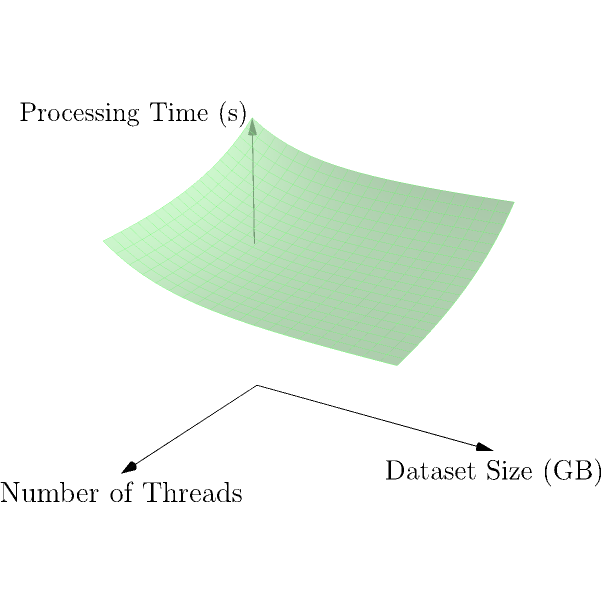The surface shown in the graph represents the relationship between processing time (z-axis), number of threads (x-axis), and dataset size (y-axis) for a multi-threading algorithm. The surface is defined by the function:

$$ f(x,y) = 100 + 50e^{-x/10} + 30e^{-y/5} $$

where $x$ represents the number of threads, $y$ represents the dataset size in GB, and $f(x,y)$ represents the processing time in seconds.

Calculate the volume enclosed between this surface and the xy-plane for $x \in [0,20]$ and $y \in [0,20]$. To find the volume enclosed between the surface and the xy-plane, we need to calculate a double integral over the given domain. The steps are as follows:

1) The volume is given by the double integral:

   $$ V = \int_{0}^{20} \int_{0}^{20} f(x,y) \, dx \, dy $$

2) Substituting the function:

   $$ V = \int_{0}^{20} \int_{0}^{20} (100 + 50e^{-x/10} + 30e^{-y/5}) \, dx \, dy $$

3) We can split this into three integrals:

   $$ V = \int_{0}^{20} \int_{0}^{20} 100 \, dx \, dy + \int_{0}^{20} \int_{0}^{20} 50e^{-x/10} \, dx \, dy + \int_{0}^{20} \int_{0}^{20} 30e^{-y/5} \, dx \, dy $$

4) Evaluating the first integral:

   $$ V_1 = 100 \cdot 20 \cdot 20 = 40,000 $$

5) For the second integral:

   $$ V_2 = \int_{0}^{20} \left[ -500e^{-x/10} \right]_{0}^{20} \, dy = \int_{0}^{20} 500(1 - e^{-2}) \, dy = 10,000(1 - e^{-2}) $$

6) For the third integral:

   $$ V_3 = \int_{0}^{20} 30e^{-y/5} \cdot 20 \, dy = 600 \left[ -5e^{-y/5} \right]_{0}^{20} = 3000(1 - e^{-4}) $$

7) The total volume is the sum of these three parts:

   $$ V = 40,000 + 10,000(1 - e^{-2}) + 3000(1 - e^{-4}) $$

8) Calculating the final result:

   $$ V \approx 52,645.97 $$
Answer: 52,645.97 cubic units 